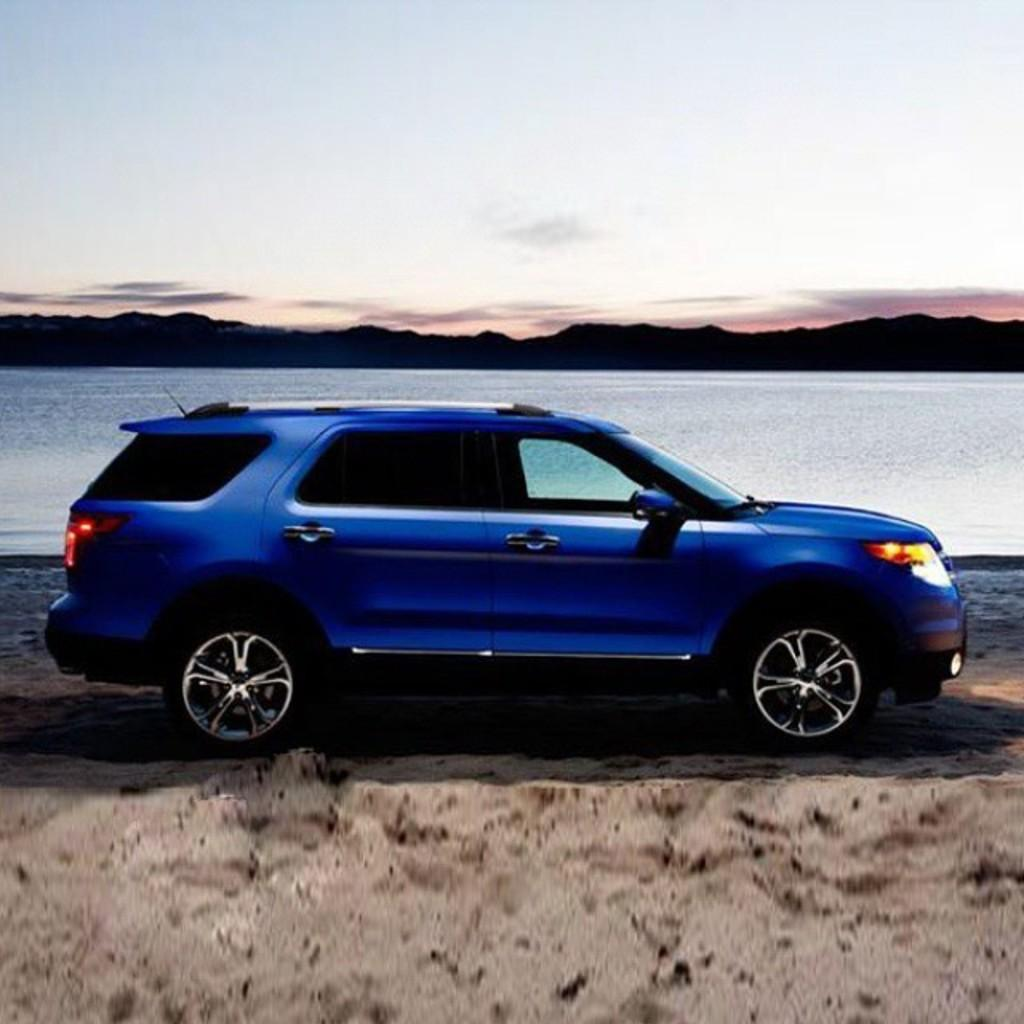What is the main subject in the center of the image? There is a car in the center of the image. What type of terrain is visible at the bottom of the image? There is sand at the bottom of the image. What natural features can be seen in the background of the image? There is a river, mountains, and a walkway in the background of the image. What part of the natural environment is visible at the top of the image? The sky is visible at the top of the image. How does the car blow bubbles in the image? The car does not blow bubbles in the image; it is a stationary object. 